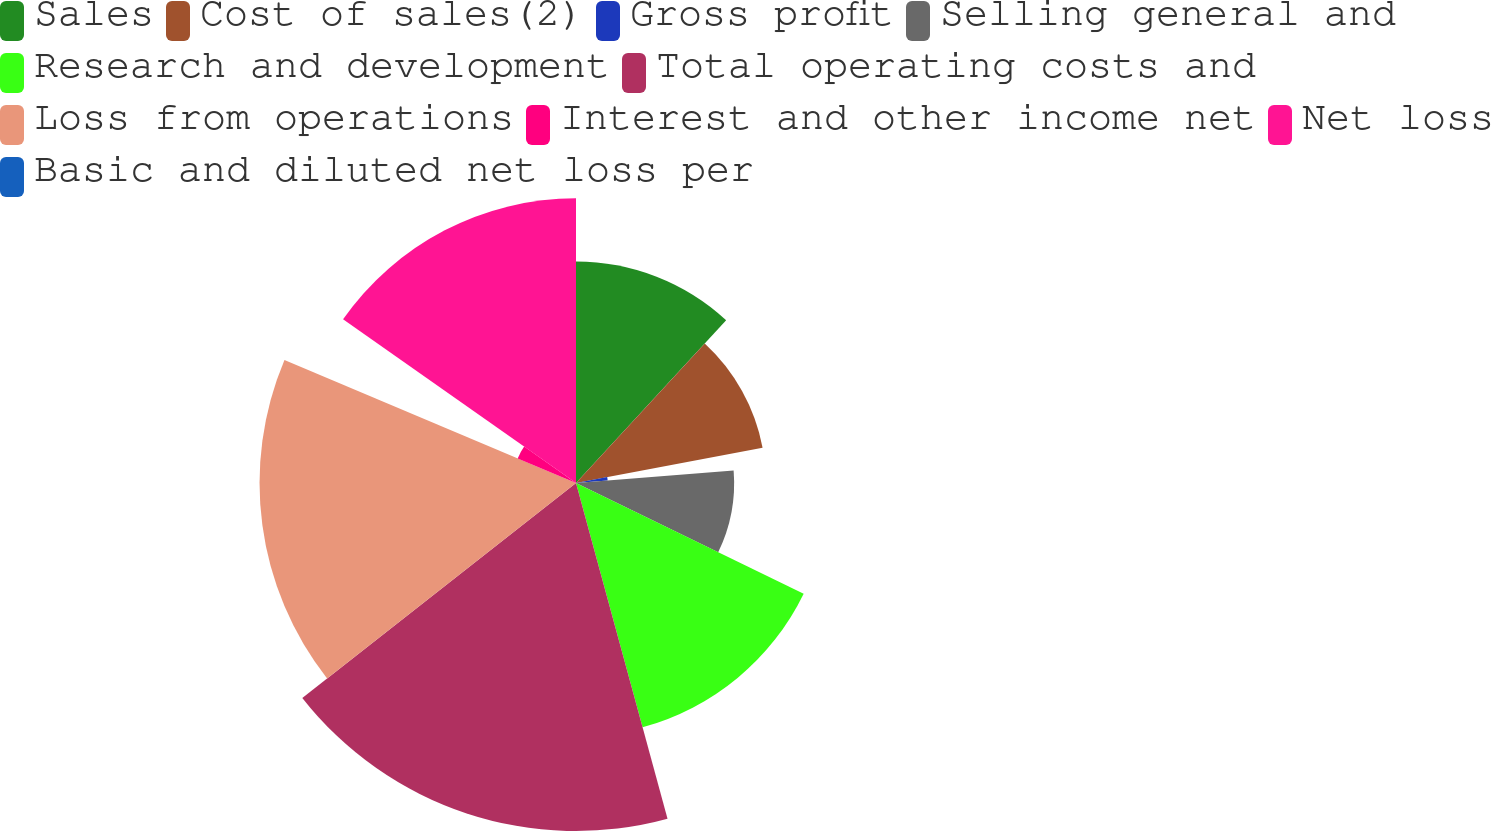Convert chart. <chart><loc_0><loc_0><loc_500><loc_500><pie_chart><fcel>Sales<fcel>Cost of sales(2)<fcel>Gross profit<fcel>Selling general and<fcel>Research and development<fcel>Total operating costs and<fcel>Loss from operations<fcel>Interest and other income net<fcel>Net loss<fcel>Basic and diluted net loss per<nl><fcel>11.86%<fcel>10.17%<fcel>1.7%<fcel>8.47%<fcel>13.56%<fcel>18.64%<fcel>16.95%<fcel>3.39%<fcel>15.25%<fcel>0.0%<nl></chart> 